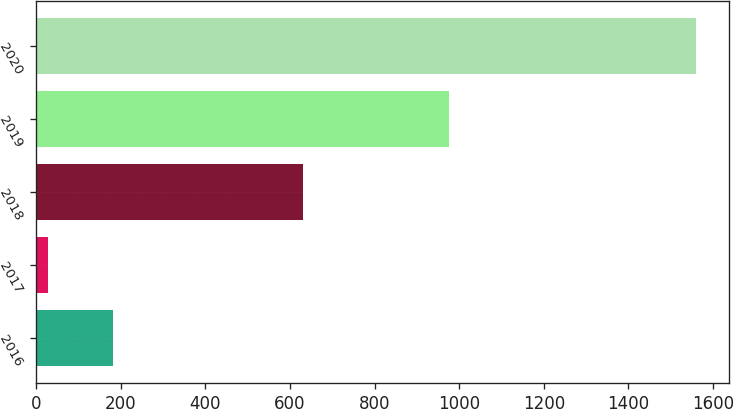Convert chart to OTSL. <chart><loc_0><loc_0><loc_500><loc_500><bar_chart><fcel>2016<fcel>2017<fcel>2018<fcel>2019<fcel>2020<nl><fcel>181.2<fcel>28<fcel>630<fcel>977<fcel>1560<nl></chart> 